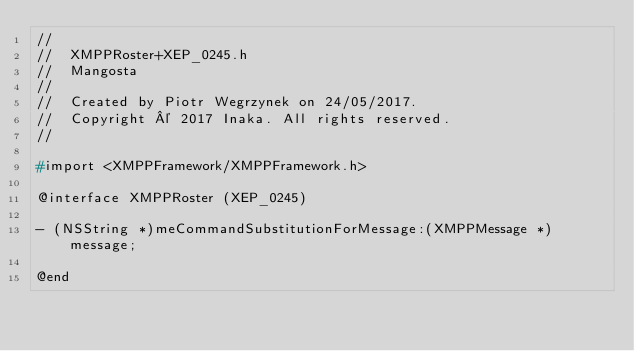Convert code to text. <code><loc_0><loc_0><loc_500><loc_500><_C_>//
//  XMPPRoster+XEP_0245.h
//  Mangosta
//
//  Created by Piotr Wegrzynek on 24/05/2017.
//  Copyright © 2017 Inaka. All rights reserved.
//

#import <XMPPFramework/XMPPFramework.h>

@interface XMPPRoster (XEP_0245)

- (NSString *)meCommandSubstitutionForMessage:(XMPPMessage *)message;

@end
</code> 